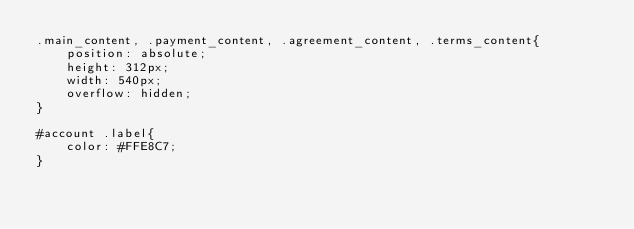<code> <loc_0><loc_0><loc_500><loc_500><_CSS_>.main_content, .payment_content, .agreement_content, .terms_content{
    position: absolute;
    height: 312px;
    width: 540px;
    overflow: hidden;
}

#account .label{
    color: #FFE8C7;
}</code> 